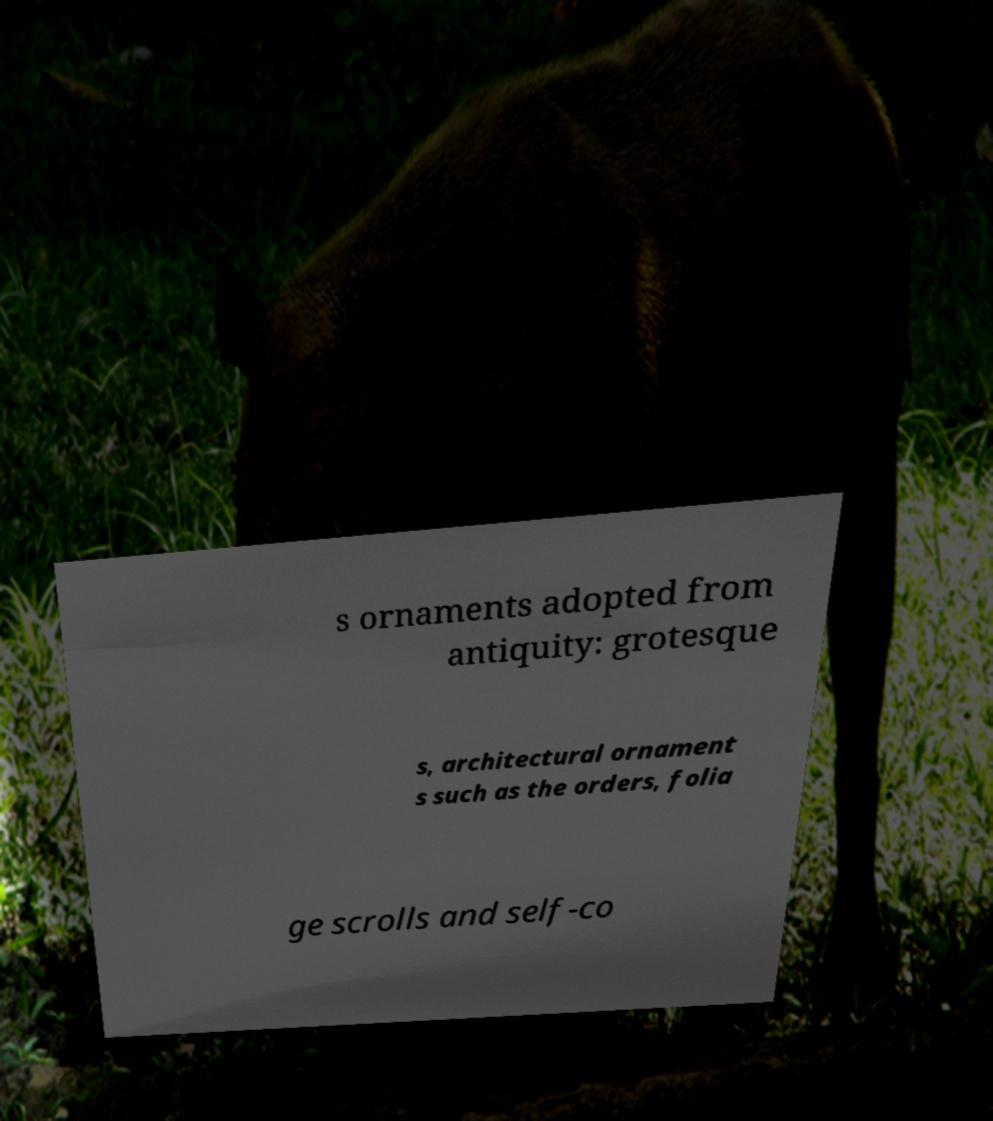Could you assist in decoding the text presented in this image and type it out clearly? s ornaments adopted from antiquity: grotesque s, architectural ornament s such as the orders, folia ge scrolls and self-co 